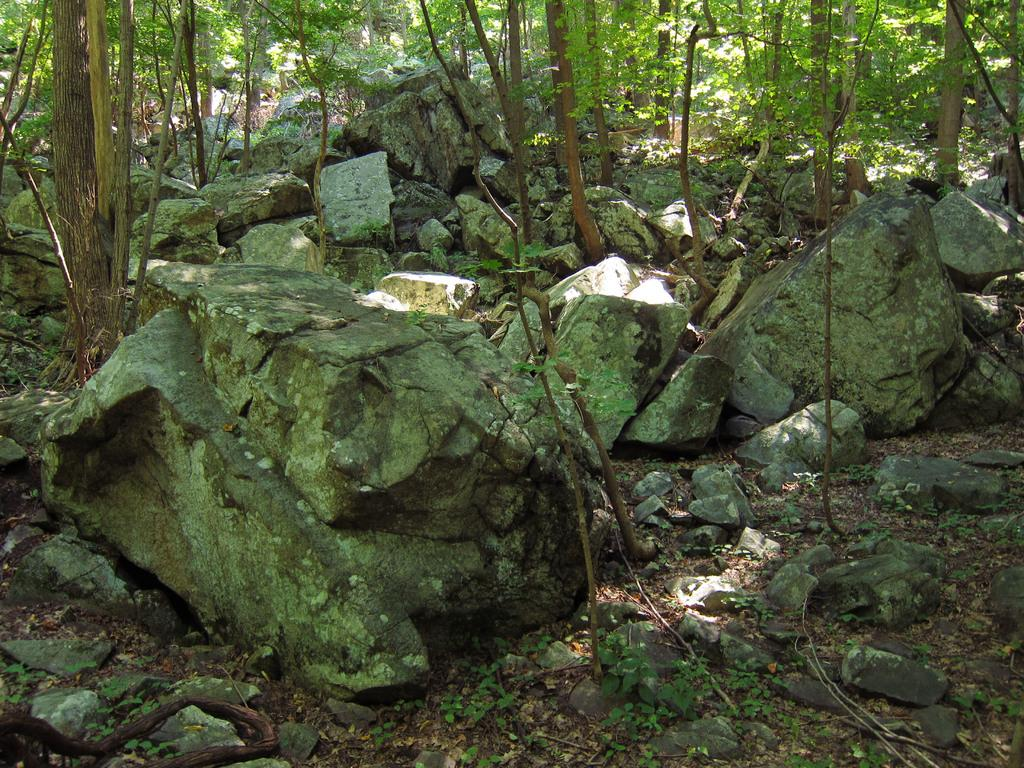What type of natural elements can be seen in the image? There are rocks, plants, and trees in the image. Can you describe the vegetation in the image? The image contains plants and trees. What is the primary difference between the plants and trees in the image? The trees are typically taller and have a more defined trunk compared to the plants. What year is depicted in the image? The image does not depict a specific year; it is a photograph of natural elements. What type of border surrounds the image? The image does not have a border; it is a photograph of natural elements. 